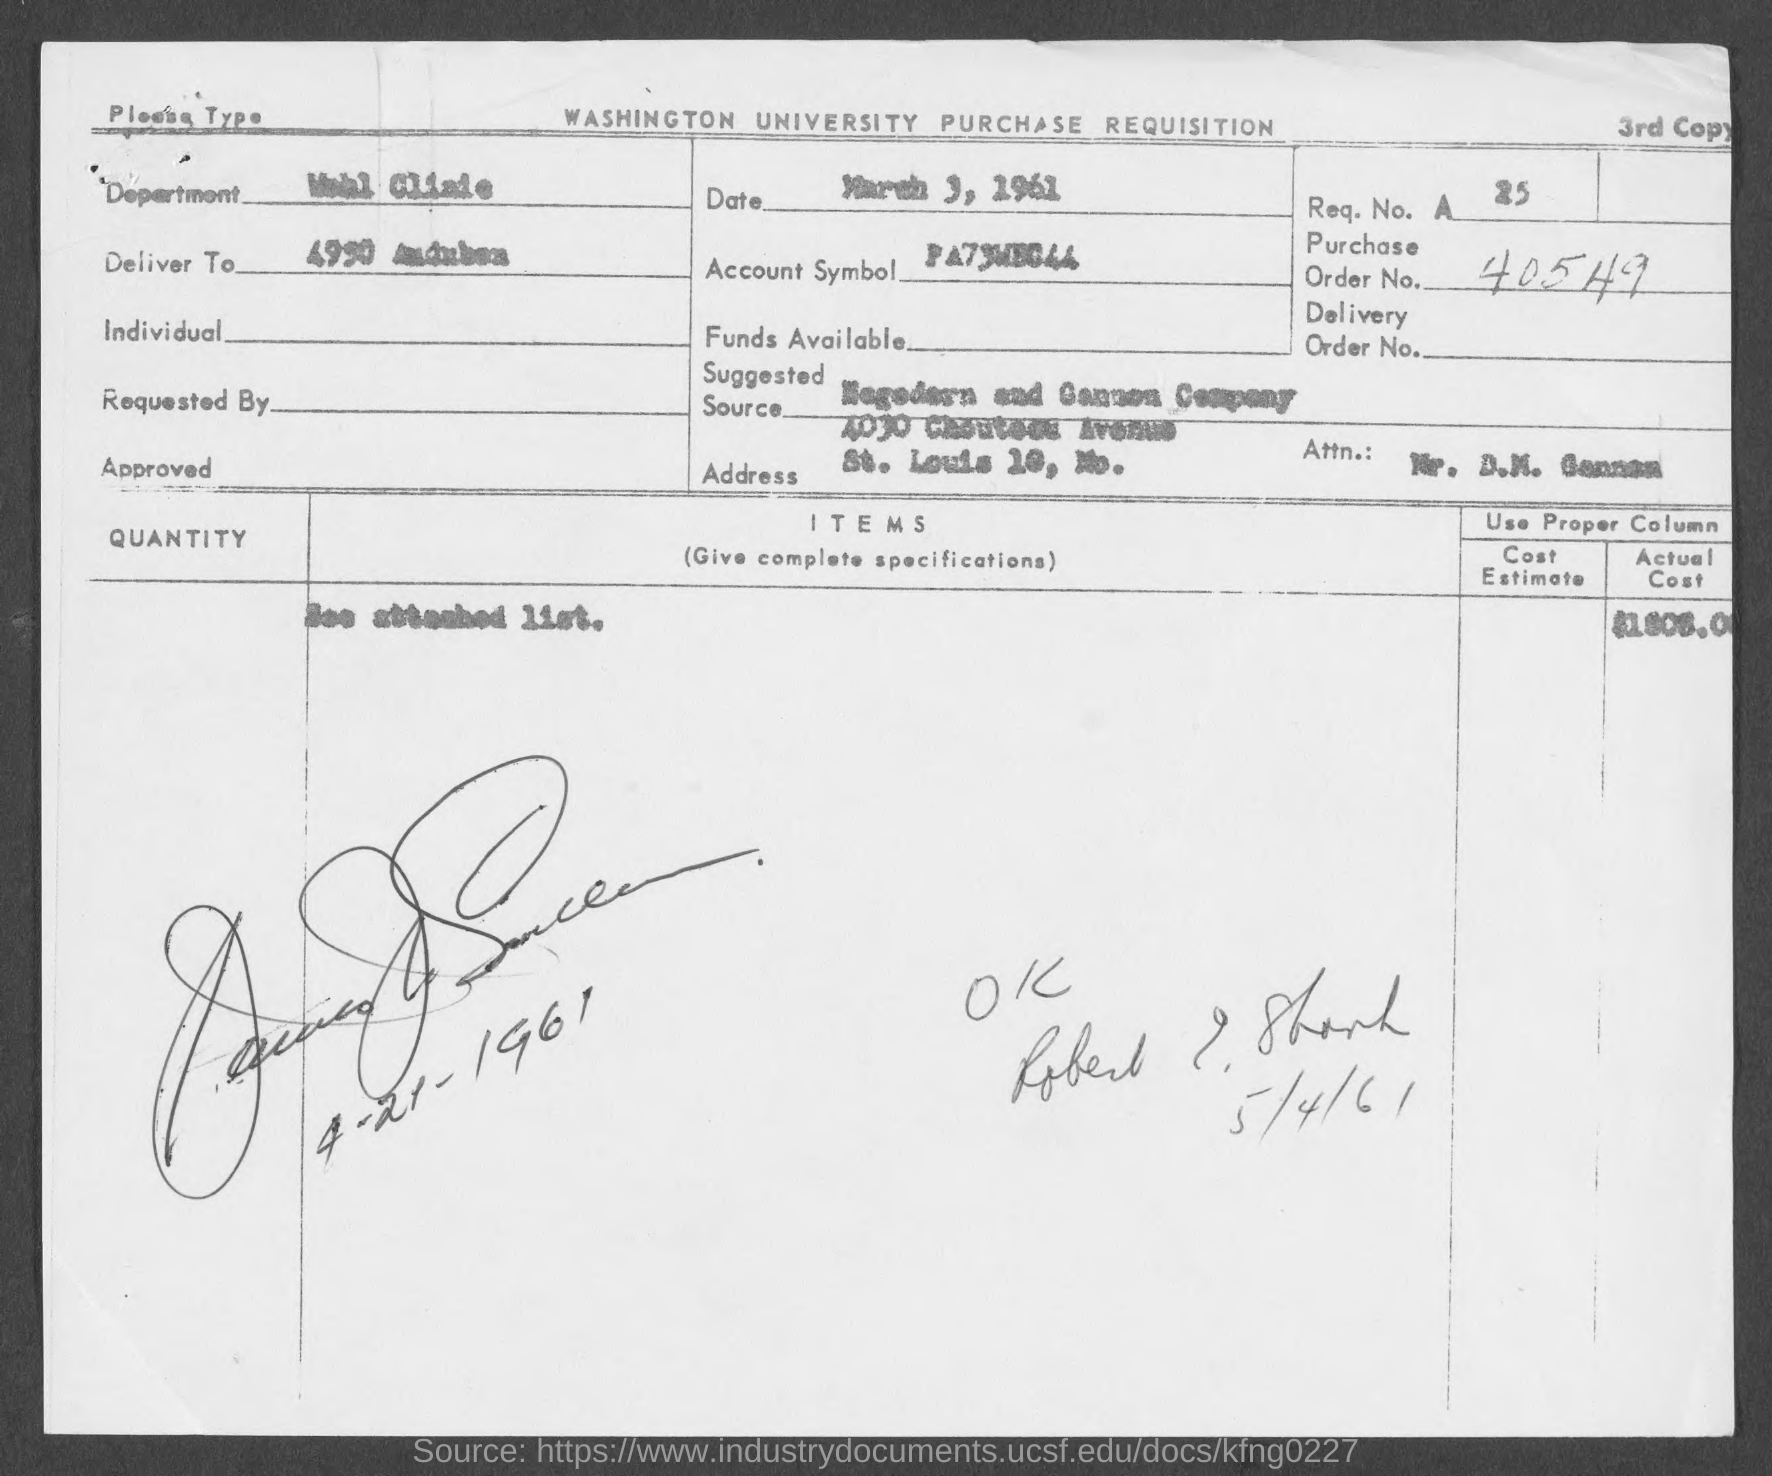What is the Date?
Offer a very short reply. March 3, 1961. What is the order no.?
Your response must be concise. 40549. 